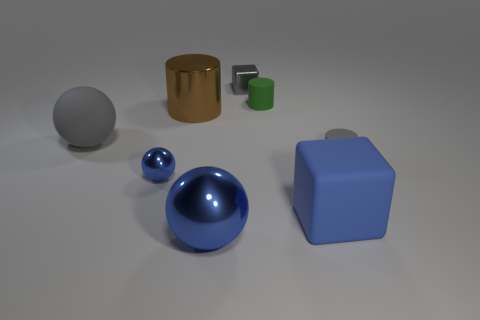How many tiny objects are either rubber cylinders or brown shiny cylinders? 2 